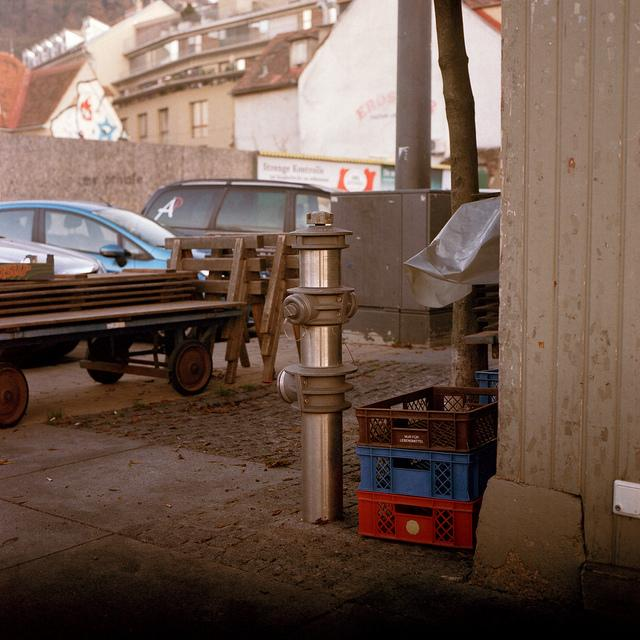What is stacked up near the wall on the right? Please explain your reasoning. crates. There are a bunch of open boxes stacked. 